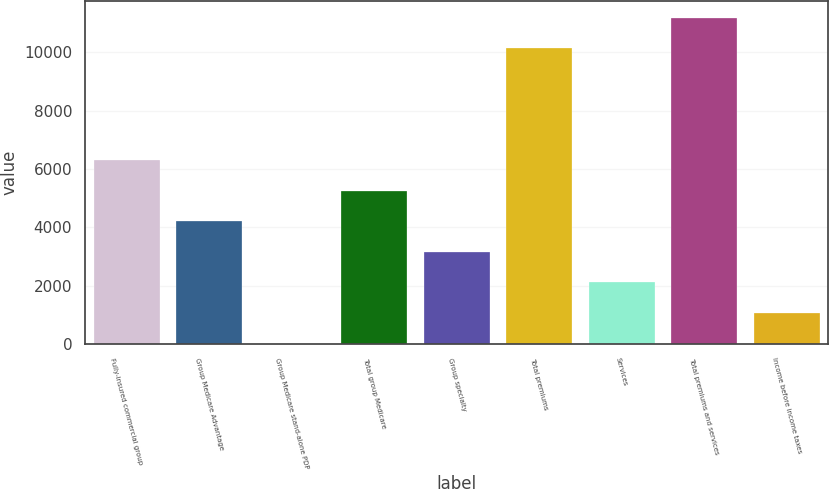<chart> <loc_0><loc_0><loc_500><loc_500><bar_chart><fcel>Fully-insured commercial group<fcel>Group Medicare Advantage<fcel>Group Medicare stand-alone PDP<fcel>Total group Medicare<fcel>Group specialty<fcel>Total premiums<fcel>Services<fcel>Total premiums and services<fcel>Income before income taxes<nl><fcel>6308<fcel>4208<fcel>8<fcel>5258<fcel>3158<fcel>10138<fcel>2108<fcel>11188<fcel>1058<nl></chart> 